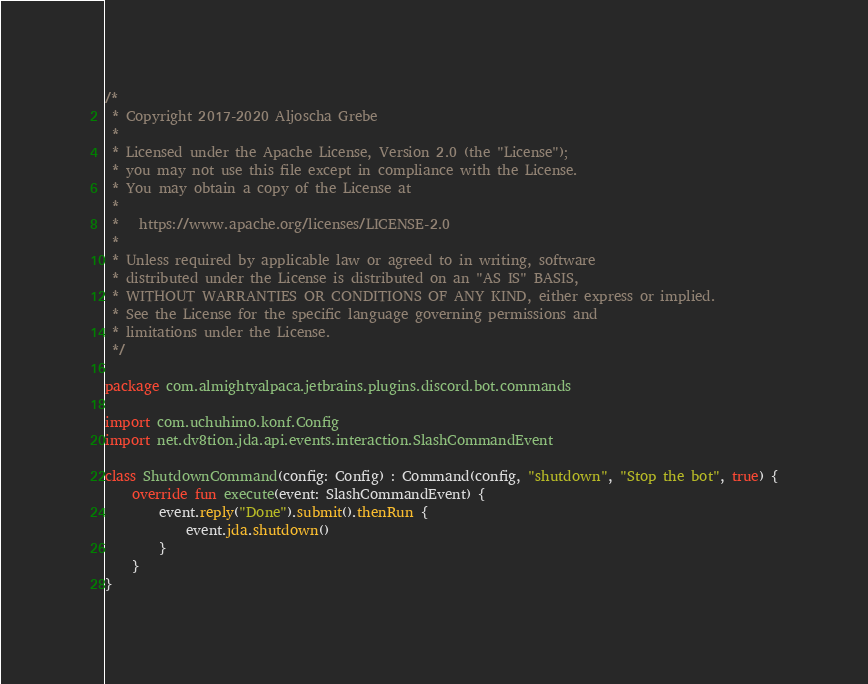<code> <loc_0><loc_0><loc_500><loc_500><_Kotlin_>/*
 * Copyright 2017-2020 Aljoscha Grebe
 *
 * Licensed under the Apache License, Version 2.0 (the "License");
 * you may not use this file except in compliance with the License.
 * You may obtain a copy of the License at
 *
 *   https://www.apache.org/licenses/LICENSE-2.0
 *
 * Unless required by applicable law or agreed to in writing, software
 * distributed under the License is distributed on an "AS IS" BASIS,
 * WITHOUT WARRANTIES OR CONDITIONS OF ANY KIND, either express or implied.
 * See the License for the specific language governing permissions and
 * limitations under the License.
 */

package com.almightyalpaca.jetbrains.plugins.discord.bot.commands

import com.uchuhimo.konf.Config
import net.dv8tion.jda.api.events.interaction.SlashCommandEvent

class ShutdownCommand(config: Config) : Command(config, "shutdown", "Stop the bot", true) {
    override fun execute(event: SlashCommandEvent) {
        event.reply("Done").submit().thenRun {
            event.jda.shutdown()
        }
    }
}
</code> 